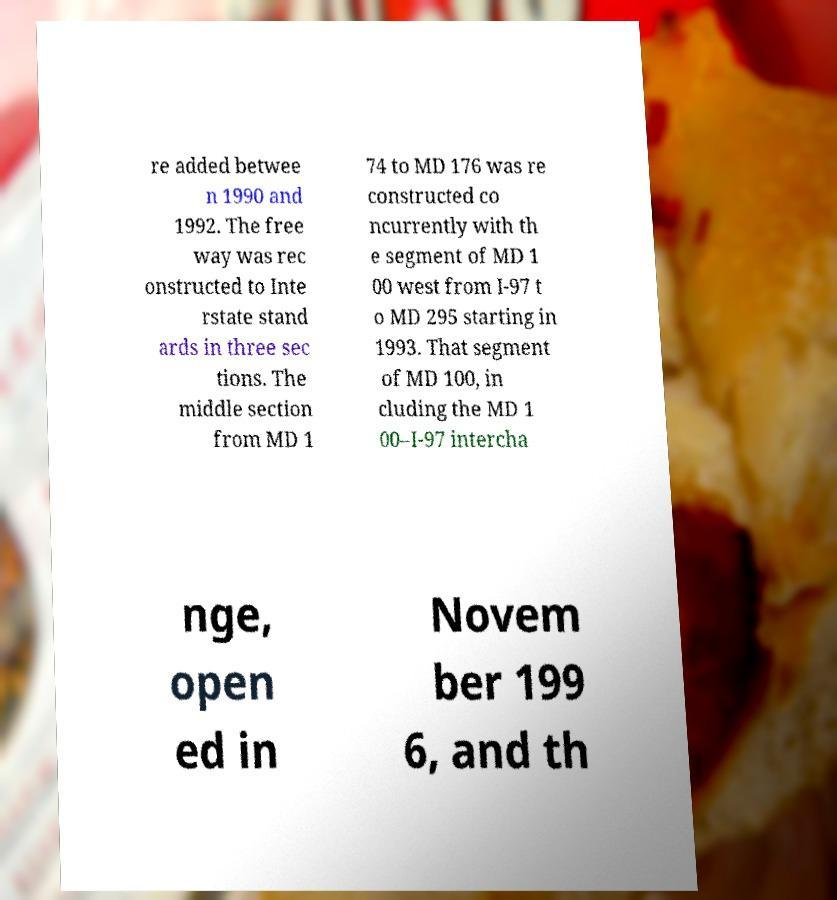Could you extract and type out the text from this image? re added betwee n 1990 and 1992. The free way was rec onstructed to Inte rstate stand ards in three sec tions. The middle section from MD 1 74 to MD 176 was re constructed co ncurrently with th e segment of MD 1 00 west from I-97 t o MD 295 starting in 1993. That segment of MD 100, in cluding the MD 1 00–I-97 intercha nge, open ed in Novem ber 199 6, and th 